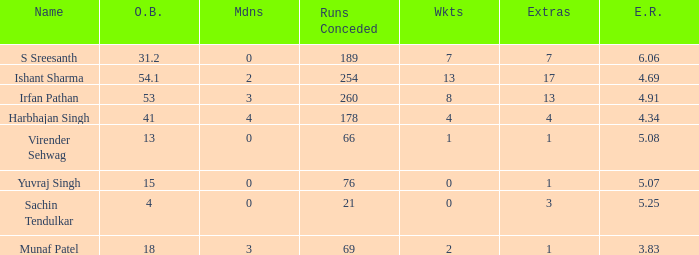Name the name for when overs bowled is 31.2 S Sreesanth. 